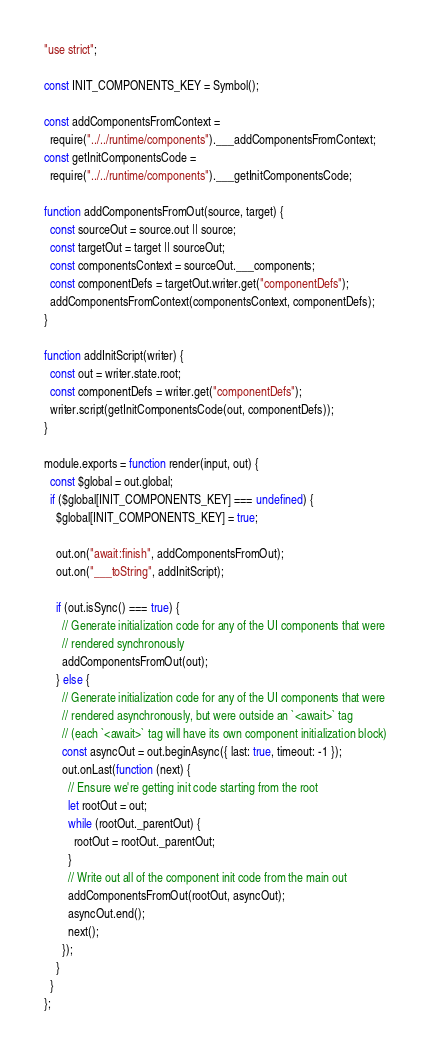<code> <loc_0><loc_0><loc_500><loc_500><_JavaScript_>"use strict";

const INIT_COMPONENTS_KEY = Symbol();

const addComponentsFromContext =
  require("../../runtime/components").___addComponentsFromContext;
const getInitComponentsCode =
  require("../../runtime/components").___getInitComponentsCode;

function addComponentsFromOut(source, target) {
  const sourceOut = source.out || source;
  const targetOut = target || sourceOut;
  const componentsContext = sourceOut.___components;
  const componentDefs = targetOut.writer.get("componentDefs");
  addComponentsFromContext(componentsContext, componentDefs);
}

function addInitScript(writer) {
  const out = writer.state.root;
  const componentDefs = writer.get("componentDefs");
  writer.script(getInitComponentsCode(out, componentDefs));
}

module.exports = function render(input, out) {
  const $global = out.global;
  if ($global[INIT_COMPONENTS_KEY] === undefined) {
    $global[INIT_COMPONENTS_KEY] = true;

    out.on("await:finish", addComponentsFromOut);
    out.on("___toString", addInitScript);

    if (out.isSync() === true) {
      // Generate initialization code for any of the UI components that were
      // rendered synchronously
      addComponentsFromOut(out);
    } else {
      // Generate initialization code for any of the UI components that were
      // rendered asynchronously, but were outside an `<await>` tag
      // (each `<await>` tag will have its own component initialization block)
      const asyncOut = out.beginAsync({ last: true, timeout: -1 });
      out.onLast(function (next) {
        // Ensure we're getting init code starting from the root
        let rootOut = out;
        while (rootOut._parentOut) {
          rootOut = rootOut._parentOut;
        }
        // Write out all of the component init code from the main out
        addComponentsFromOut(rootOut, asyncOut);
        asyncOut.end();
        next();
      });
    }
  }
};
</code> 